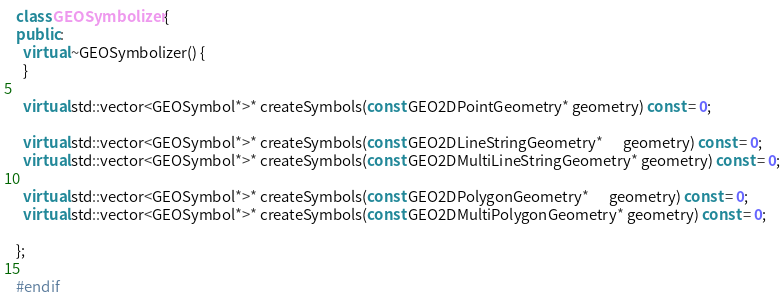<code> <loc_0><loc_0><loc_500><loc_500><_C++_>class GEOSymbolizer {
public:
  virtual ~GEOSymbolizer() {
  }

  virtual std::vector<GEOSymbol*>* createSymbols(const GEO2DPointGeometry* geometry) const = 0;

  virtual std::vector<GEOSymbol*>* createSymbols(const GEO2DLineStringGeometry*      geometry) const = 0;
  virtual std::vector<GEOSymbol*>* createSymbols(const GEO2DMultiLineStringGeometry* geometry) const = 0;

  virtual std::vector<GEOSymbol*>* createSymbols(const GEO2DPolygonGeometry*      geometry) const = 0;
  virtual std::vector<GEOSymbol*>* createSymbols(const GEO2DMultiPolygonGeometry* geometry) const = 0;

};

#endif
</code> 